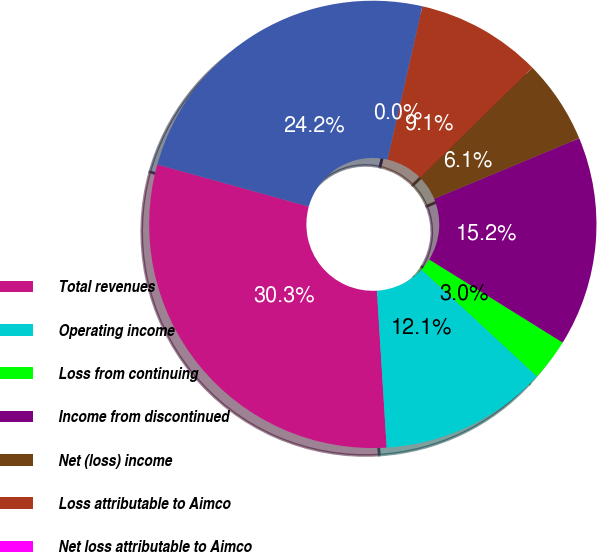Convert chart to OTSL. <chart><loc_0><loc_0><loc_500><loc_500><pie_chart><fcel>Total revenues<fcel>Operating income<fcel>Loss from continuing<fcel>Income from discontinued<fcel>Net (loss) income<fcel>Loss attributable to Aimco<fcel>Net loss attributable to Aimco<fcel>Weighted average common shares<nl><fcel>30.3%<fcel>12.12%<fcel>3.03%<fcel>15.15%<fcel>6.06%<fcel>9.09%<fcel>0.0%<fcel>24.24%<nl></chart> 